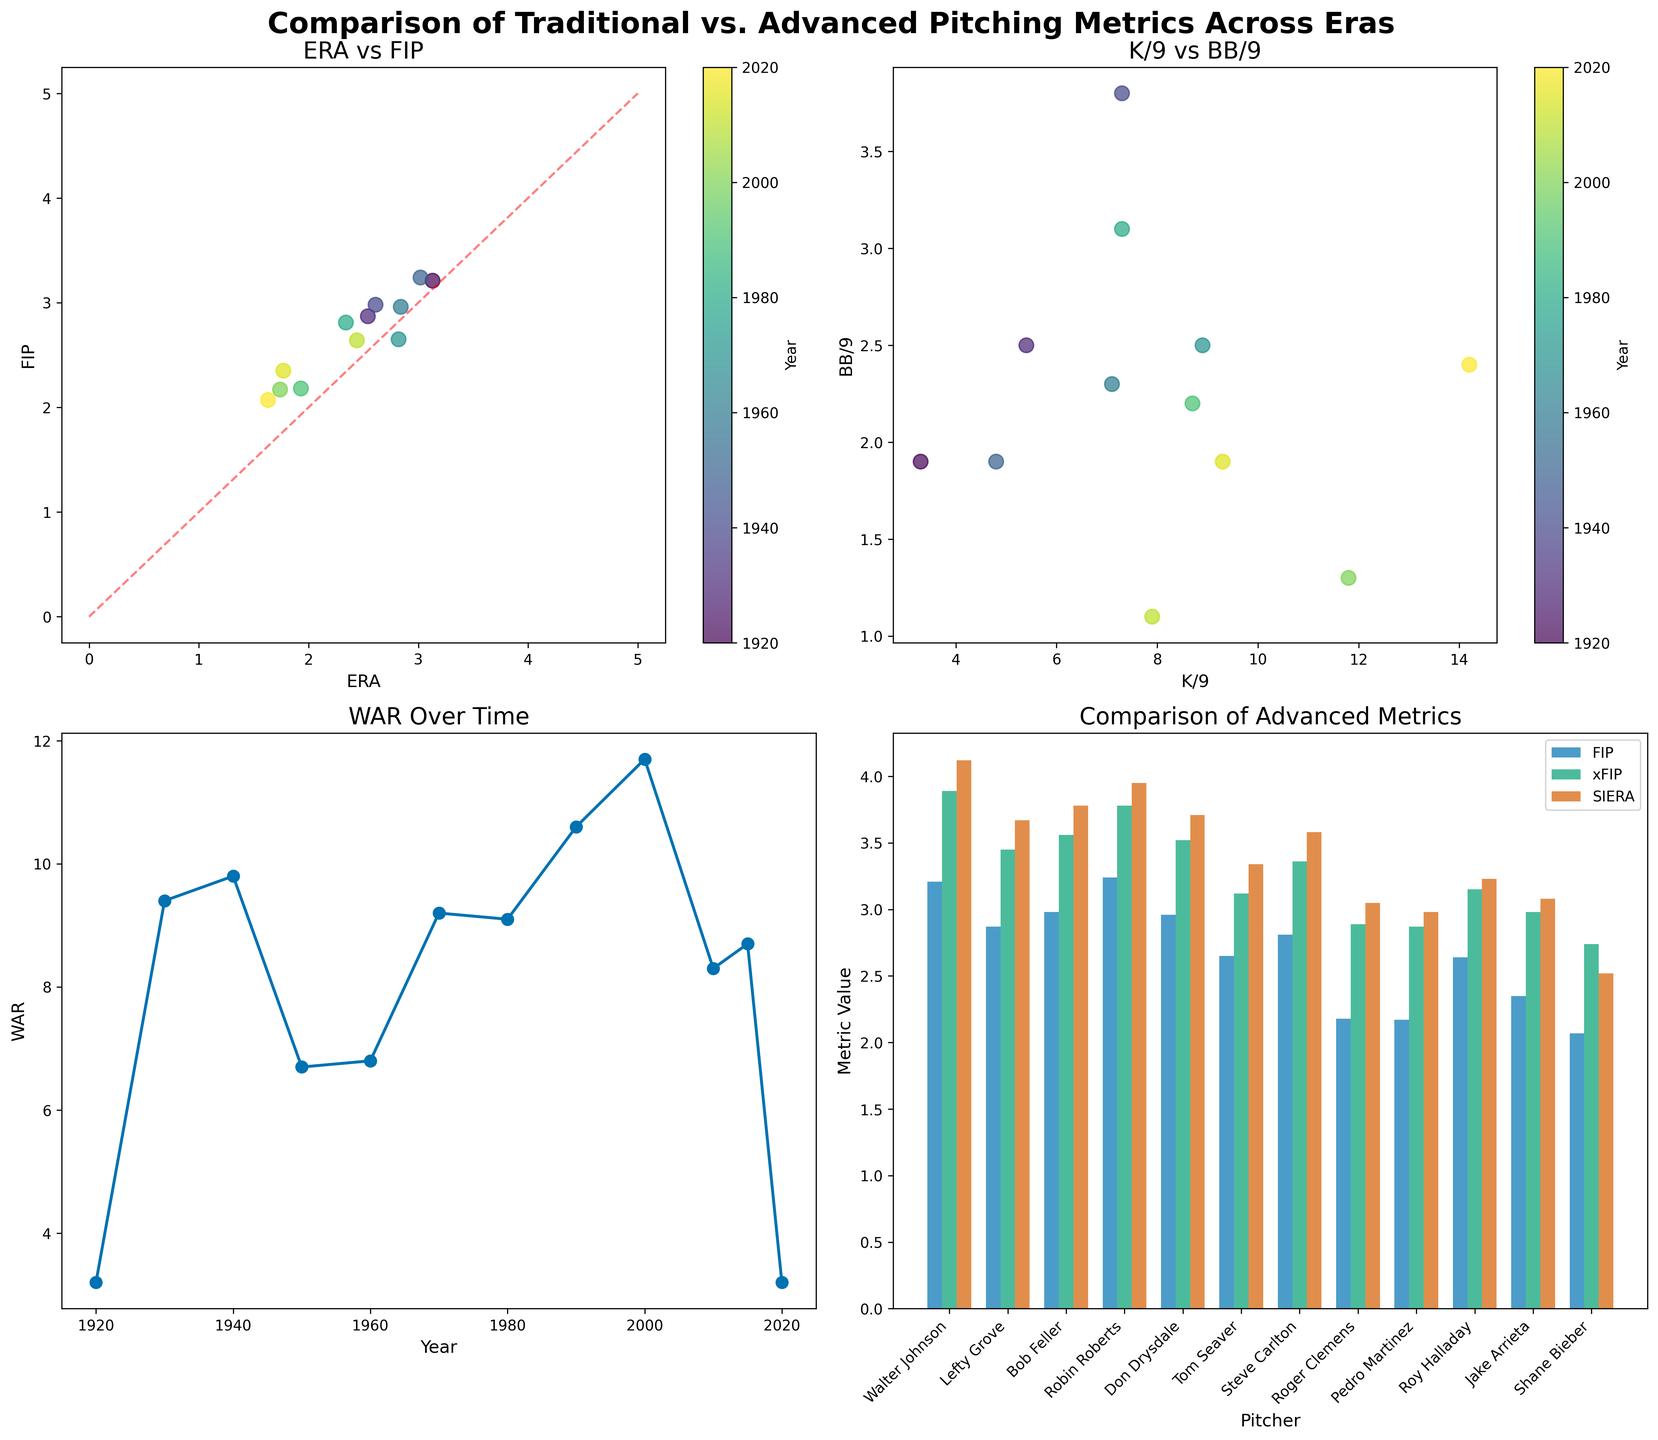ERA vs FIP often show different values for pitchers from different eras. Are there any pitchers where ERA and FIP are almost the same? To answer this, look at the ERA vs. FIP subplot and identify points that are closest to the diagonal line (which would indicate equal values). Points near the red dashed line represent pitchers whose ERA and FIP are almost the same.
Answer: Don Drysdale (1960) and Robin Roberts (1950) How has WAR trended over time from pre-integration to the modern era? Check the "WAR Over Time" subplot. Look at the markers from left (earliest years) to right (most recent years) to observe if there's an increasing, decreasing, or fluctuating trend. It appears there are fluctuations, with some peaks and troughs.
Answer: Fluctuating trend Compared to Shane Bieber (2020), who has the highest FIP among all listed pitchers? Refer to the "Comparison of Advanced Metrics" bar chart. The tallest bar in the FIP category compared to Shane Bieber's bar will indicate the pitcher with the highest FIP.
Answer: Lefty Grove (1930) In the scatter plot of ERA vs FIP, which era has a cluster of points with lower ERA values? Observe the "ERA vs FIP" scatterplot and focus on the color that corresponds to specific eras. Identify which era’s color cluster largely sits in the lower region of the ERA axis. The modern era, indicated by specific colors, tends to have lower ERA values.
Answer: Modern Era Between the years 2000 and 2010, how do WAR values compare? Referring to the "WAR Over Time" subplot, locate WAR values for 2000 and 2010. Compare the heights of the plotted points at these specific years.
Answer: WAR in 2000 is higher In the K/9 vs BB/9 scatter plot, which pitcher has the highest strikeout rate (K/9)? Refer to the "K/9 vs BB/9" scatterplot and identify the point that is farthest right (higher K/9 values). The color will indicate the pitcher and corresponding year.
Answer: Shane Bieber (2020) Which pitcher from the Free Agency era has the lowest SIERA, according to the bar chart? Look at the "Comparison of Advanced Metrics" subplot. Check the SIERA bars for the pitchers from the Free Agency era and find the lowest bar.
Answer: Pedro Martinez (2000) How do the FIP and xFIP values of Pedro Martinez (2000) compare? Refer to the "Comparison of Advanced Metrics" bar chart. Identify the bars for Pedro Martinez and compare the height of the FIP and xFIP bars.
Answer: FIP and xFIP are almost the same for Pedro Martinez In the ERA vs FIP scatter plot, which pitcher from the pre-integration era has the highest ERA? Observe the "ERA vs FIP" scatterplot and look for the points labeled with pre-integration era colors. Identify the highest point on the ERA axis.
Answer: Walter Johnson (1920) Across all data points, who has the least amount of WAR, and in which year? Look at the lowest point in the "WAR Over Time" subplot, and check the year and the pitcher's name associated with that point.
Answer: Walter Johnson (1920) and Shane Bieber (2020) both have the lowest WAR 